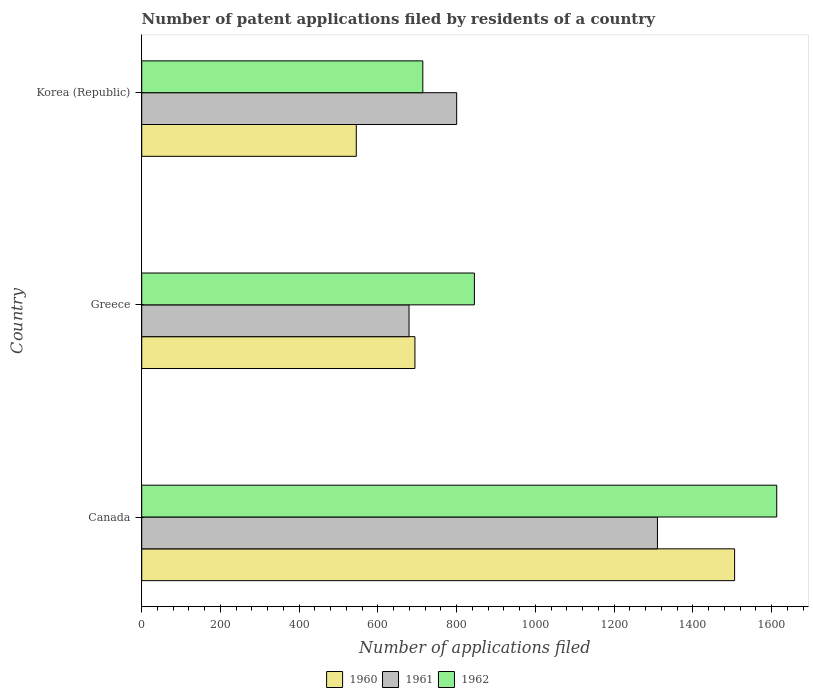Are the number of bars per tick equal to the number of legend labels?
Provide a succinct answer. Yes. How many bars are there on the 1st tick from the top?
Keep it short and to the point. 3. What is the label of the 2nd group of bars from the top?
Provide a succinct answer. Greece. What is the number of applications filed in 1962 in Canada?
Your answer should be very brief. 1613. Across all countries, what is the maximum number of applications filed in 1960?
Provide a succinct answer. 1506. Across all countries, what is the minimum number of applications filed in 1962?
Provide a succinct answer. 714. In which country was the number of applications filed in 1962 maximum?
Give a very brief answer. Canada. What is the total number of applications filed in 1960 in the graph?
Your answer should be compact. 2745. What is the difference between the number of applications filed in 1961 in Greece and that in Korea (Republic)?
Your answer should be compact. -121. What is the difference between the number of applications filed in 1960 in Canada and the number of applications filed in 1962 in Korea (Republic)?
Offer a very short reply. 792. What is the average number of applications filed in 1960 per country?
Provide a succinct answer. 915. What is the difference between the number of applications filed in 1961 and number of applications filed in 1960 in Korea (Republic)?
Provide a succinct answer. 255. In how many countries, is the number of applications filed in 1961 greater than 1280 ?
Your answer should be very brief. 1. What is the ratio of the number of applications filed in 1962 in Greece to that in Korea (Republic)?
Provide a succinct answer. 1.18. What is the difference between the highest and the second highest number of applications filed in 1962?
Offer a very short reply. 768. What is the difference between the highest and the lowest number of applications filed in 1961?
Make the answer very short. 631. In how many countries, is the number of applications filed in 1961 greater than the average number of applications filed in 1961 taken over all countries?
Your answer should be very brief. 1. How many bars are there?
Your answer should be very brief. 9. Are all the bars in the graph horizontal?
Keep it short and to the point. Yes. How many countries are there in the graph?
Ensure brevity in your answer.  3. What is the difference between two consecutive major ticks on the X-axis?
Make the answer very short. 200. Are the values on the major ticks of X-axis written in scientific E-notation?
Ensure brevity in your answer.  No. Does the graph contain any zero values?
Provide a succinct answer. No. Where does the legend appear in the graph?
Provide a succinct answer. Bottom center. How are the legend labels stacked?
Your response must be concise. Horizontal. What is the title of the graph?
Ensure brevity in your answer.  Number of patent applications filed by residents of a country. Does "2012" appear as one of the legend labels in the graph?
Give a very brief answer. No. What is the label or title of the X-axis?
Your answer should be very brief. Number of applications filed. What is the Number of applications filed in 1960 in Canada?
Offer a very short reply. 1506. What is the Number of applications filed in 1961 in Canada?
Keep it short and to the point. 1310. What is the Number of applications filed of 1962 in Canada?
Give a very brief answer. 1613. What is the Number of applications filed in 1960 in Greece?
Offer a very short reply. 694. What is the Number of applications filed in 1961 in Greece?
Ensure brevity in your answer.  679. What is the Number of applications filed of 1962 in Greece?
Give a very brief answer. 845. What is the Number of applications filed of 1960 in Korea (Republic)?
Provide a succinct answer. 545. What is the Number of applications filed in 1961 in Korea (Republic)?
Your response must be concise. 800. What is the Number of applications filed in 1962 in Korea (Republic)?
Give a very brief answer. 714. Across all countries, what is the maximum Number of applications filed in 1960?
Your response must be concise. 1506. Across all countries, what is the maximum Number of applications filed in 1961?
Offer a terse response. 1310. Across all countries, what is the maximum Number of applications filed of 1962?
Offer a terse response. 1613. Across all countries, what is the minimum Number of applications filed in 1960?
Give a very brief answer. 545. Across all countries, what is the minimum Number of applications filed in 1961?
Provide a succinct answer. 679. Across all countries, what is the minimum Number of applications filed of 1962?
Offer a very short reply. 714. What is the total Number of applications filed of 1960 in the graph?
Provide a succinct answer. 2745. What is the total Number of applications filed of 1961 in the graph?
Offer a terse response. 2789. What is the total Number of applications filed in 1962 in the graph?
Offer a very short reply. 3172. What is the difference between the Number of applications filed of 1960 in Canada and that in Greece?
Make the answer very short. 812. What is the difference between the Number of applications filed in 1961 in Canada and that in Greece?
Your answer should be compact. 631. What is the difference between the Number of applications filed of 1962 in Canada and that in Greece?
Provide a short and direct response. 768. What is the difference between the Number of applications filed in 1960 in Canada and that in Korea (Republic)?
Your response must be concise. 961. What is the difference between the Number of applications filed of 1961 in Canada and that in Korea (Republic)?
Your response must be concise. 510. What is the difference between the Number of applications filed of 1962 in Canada and that in Korea (Republic)?
Make the answer very short. 899. What is the difference between the Number of applications filed in 1960 in Greece and that in Korea (Republic)?
Offer a terse response. 149. What is the difference between the Number of applications filed in 1961 in Greece and that in Korea (Republic)?
Keep it short and to the point. -121. What is the difference between the Number of applications filed in 1962 in Greece and that in Korea (Republic)?
Give a very brief answer. 131. What is the difference between the Number of applications filed in 1960 in Canada and the Number of applications filed in 1961 in Greece?
Make the answer very short. 827. What is the difference between the Number of applications filed in 1960 in Canada and the Number of applications filed in 1962 in Greece?
Ensure brevity in your answer.  661. What is the difference between the Number of applications filed in 1961 in Canada and the Number of applications filed in 1962 in Greece?
Ensure brevity in your answer.  465. What is the difference between the Number of applications filed in 1960 in Canada and the Number of applications filed in 1961 in Korea (Republic)?
Your response must be concise. 706. What is the difference between the Number of applications filed of 1960 in Canada and the Number of applications filed of 1962 in Korea (Republic)?
Your response must be concise. 792. What is the difference between the Number of applications filed of 1961 in Canada and the Number of applications filed of 1962 in Korea (Republic)?
Provide a succinct answer. 596. What is the difference between the Number of applications filed in 1960 in Greece and the Number of applications filed in 1961 in Korea (Republic)?
Keep it short and to the point. -106. What is the difference between the Number of applications filed of 1961 in Greece and the Number of applications filed of 1962 in Korea (Republic)?
Provide a short and direct response. -35. What is the average Number of applications filed in 1960 per country?
Offer a terse response. 915. What is the average Number of applications filed of 1961 per country?
Offer a very short reply. 929.67. What is the average Number of applications filed in 1962 per country?
Ensure brevity in your answer.  1057.33. What is the difference between the Number of applications filed of 1960 and Number of applications filed of 1961 in Canada?
Offer a terse response. 196. What is the difference between the Number of applications filed in 1960 and Number of applications filed in 1962 in Canada?
Offer a terse response. -107. What is the difference between the Number of applications filed in 1961 and Number of applications filed in 1962 in Canada?
Provide a short and direct response. -303. What is the difference between the Number of applications filed in 1960 and Number of applications filed in 1961 in Greece?
Offer a terse response. 15. What is the difference between the Number of applications filed of 1960 and Number of applications filed of 1962 in Greece?
Keep it short and to the point. -151. What is the difference between the Number of applications filed in 1961 and Number of applications filed in 1962 in Greece?
Offer a terse response. -166. What is the difference between the Number of applications filed of 1960 and Number of applications filed of 1961 in Korea (Republic)?
Make the answer very short. -255. What is the difference between the Number of applications filed in 1960 and Number of applications filed in 1962 in Korea (Republic)?
Your answer should be very brief. -169. What is the difference between the Number of applications filed of 1961 and Number of applications filed of 1962 in Korea (Republic)?
Offer a very short reply. 86. What is the ratio of the Number of applications filed of 1960 in Canada to that in Greece?
Ensure brevity in your answer.  2.17. What is the ratio of the Number of applications filed in 1961 in Canada to that in Greece?
Give a very brief answer. 1.93. What is the ratio of the Number of applications filed of 1962 in Canada to that in Greece?
Your response must be concise. 1.91. What is the ratio of the Number of applications filed of 1960 in Canada to that in Korea (Republic)?
Your response must be concise. 2.76. What is the ratio of the Number of applications filed in 1961 in Canada to that in Korea (Republic)?
Give a very brief answer. 1.64. What is the ratio of the Number of applications filed in 1962 in Canada to that in Korea (Republic)?
Your answer should be very brief. 2.26. What is the ratio of the Number of applications filed of 1960 in Greece to that in Korea (Republic)?
Keep it short and to the point. 1.27. What is the ratio of the Number of applications filed in 1961 in Greece to that in Korea (Republic)?
Offer a very short reply. 0.85. What is the ratio of the Number of applications filed of 1962 in Greece to that in Korea (Republic)?
Ensure brevity in your answer.  1.18. What is the difference between the highest and the second highest Number of applications filed in 1960?
Your answer should be compact. 812. What is the difference between the highest and the second highest Number of applications filed of 1961?
Give a very brief answer. 510. What is the difference between the highest and the second highest Number of applications filed of 1962?
Your answer should be compact. 768. What is the difference between the highest and the lowest Number of applications filed in 1960?
Your answer should be very brief. 961. What is the difference between the highest and the lowest Number of applications filed of 1961?
Provide a short and direct response. 631. What is the difference between the highest and the lowest Number of applications filed of 1962?
Give a very brief answer. 899. 